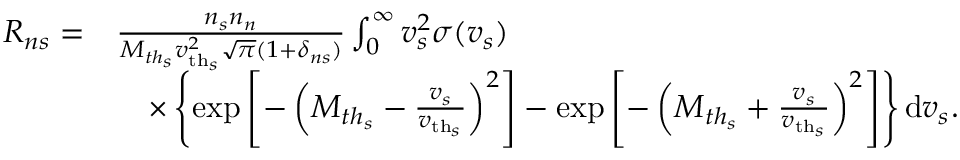<formula> <loc_0><loc_0><loc_500><loc_500>\begin{array} { r l } { R _ { n s } = } & { \frac { n _ { s } n _ { n } } { M _ { t h _ { s } } { v _ { t h _ { s } } } ^ { 2 } \sqrt { \pi } ( 1 + \delta _ { n s } ) } \int _ { 0 } ^ { \infty } v _ { s } ^ { 2 } \sigma ( v _ { s } ) } \\ & { \quad \times \left \{ \exp \left [ - \left ( M _ { t h _ { s } } - \frac { v _ { s } } { { v _ { t h _ { s } } } } \right ) ^ { 2 } \right ] - \exp \left [ - \left ( M _ { t h _ { s } } + \frac { v _ { s } } { { v _ { t h _ { s } } } } \right ) ^ { 2 } \right ] \right \} d v _ { s } . } \end{array}</formula> 